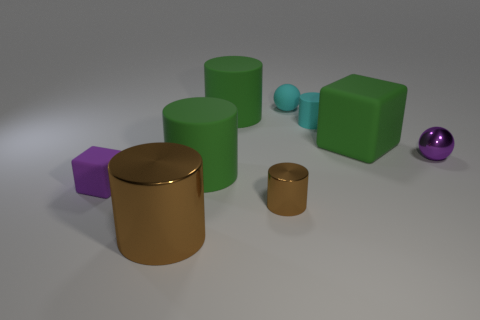Add 1 tiny brown metal objects. How many objects exist? 10 Subtract all large matte cylinders. How many cylinders are left? 3 Subtract all brown cylinders. How many cylinders are left? 3 Subtract all cylinders. How many objects are left? 4 Subtract 2 spheres. How many spheres are left? 0 Subtract all yellow cylinders. Subtract all cyan cubes. How many cylinders are left? 5 Subtract all purple cylinders. How many purple blocks are left? 1 Subtract all tiny purple matte cubes. Subtract all big green blocks. How many objects are left? 7 Add 4 small purple matte objects. How many small purple matte objects are left? 5 Add 3 tiny purple matte blocks. How many tiny purple matte blocks exist? 4 